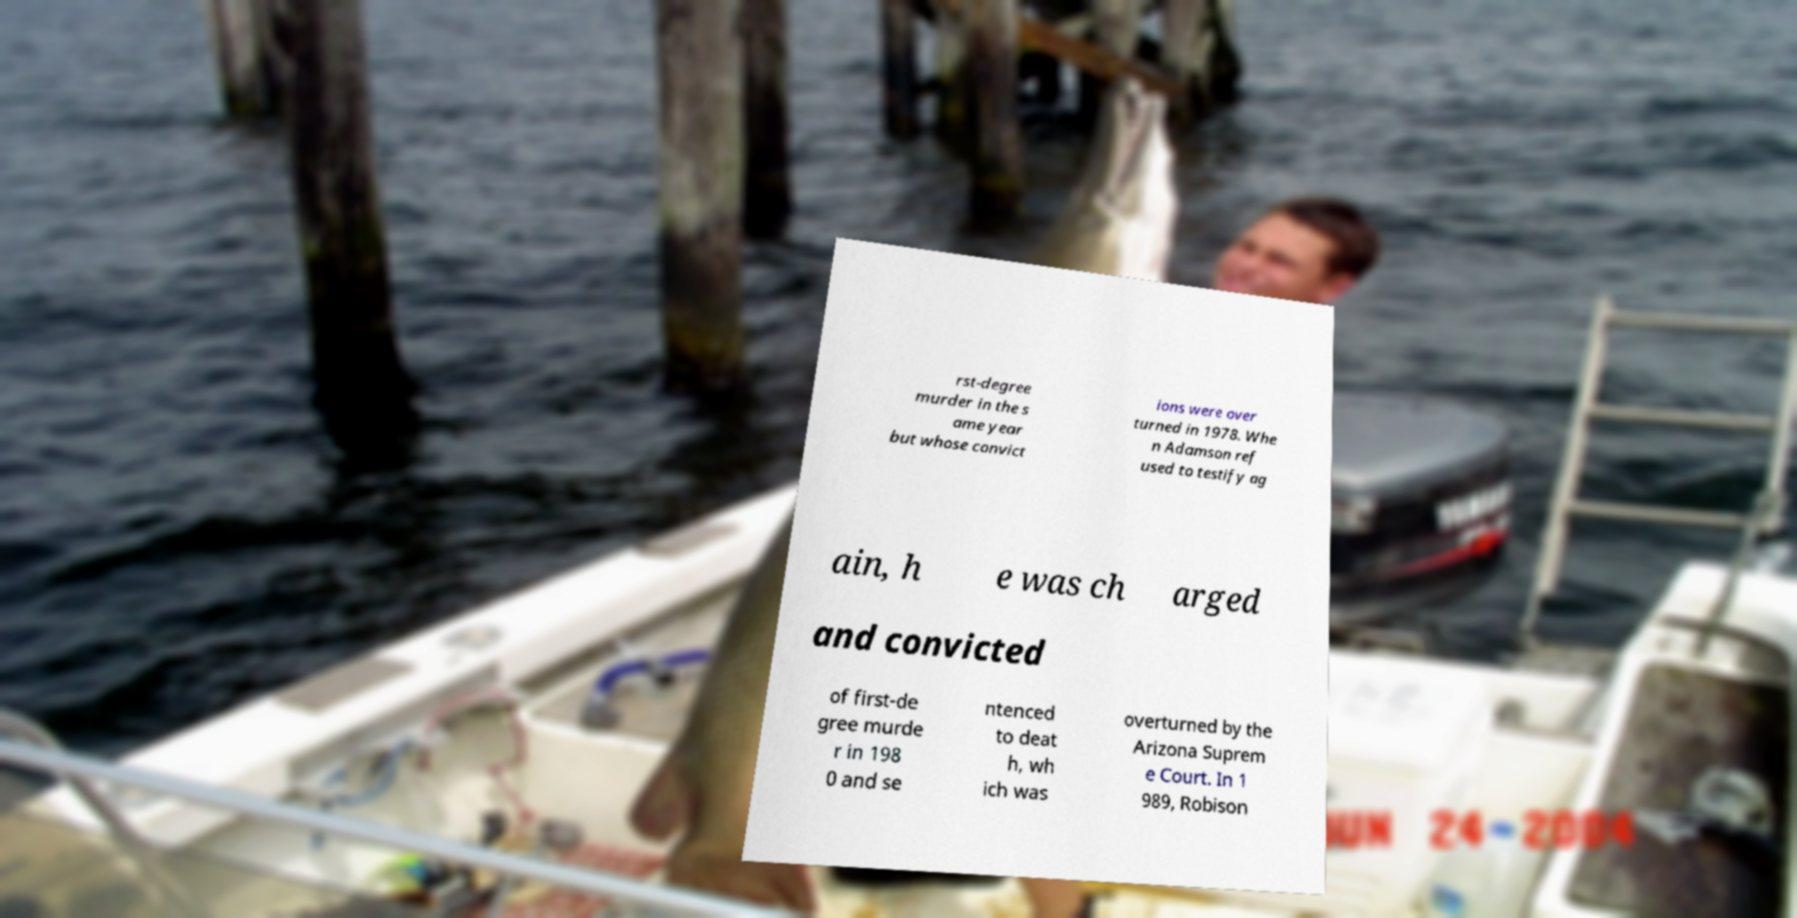Could you extract and type out the text from this image? rst-degree murder in the s ame year but whose convict ions were over turned in 1978. Whe n Adamson ref used to testify ag ain, h e was ch arged and convicted of first-de gree murde r in 198 0 and se ntenced to deat h, wh ich was overturned by the Arizona Suprem e Court. In 1 989, Robison 